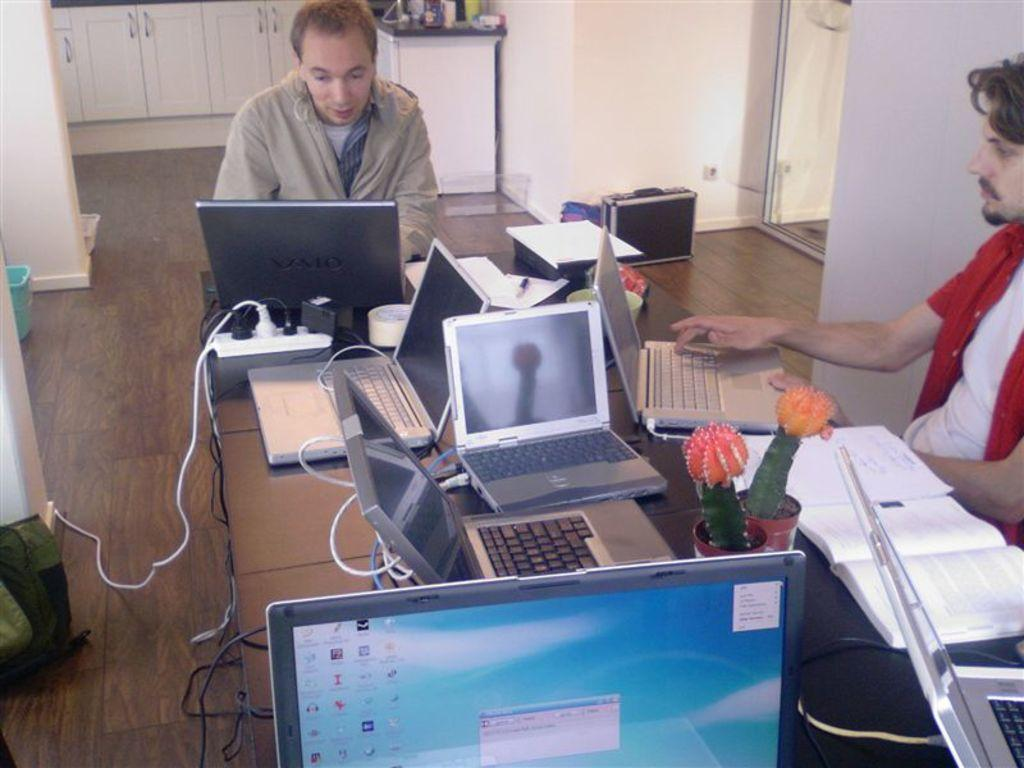Provide a one-sentence caption for the provided image. The computer at the front of the desk includes the Audacity music editing software. 